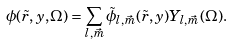Convert formula to latex. <formula><loc_0><loc_0><loc_500><loc_500>\phi ( \tilde { r } , y , \Omega ) = \sum _ { l , \vec { m } } \tilde { \phi } _ { l , \vec { m } } ( \tilde { r } , y ) Y _ { l , \vec { m } } ( \Omega ) .</formula> 